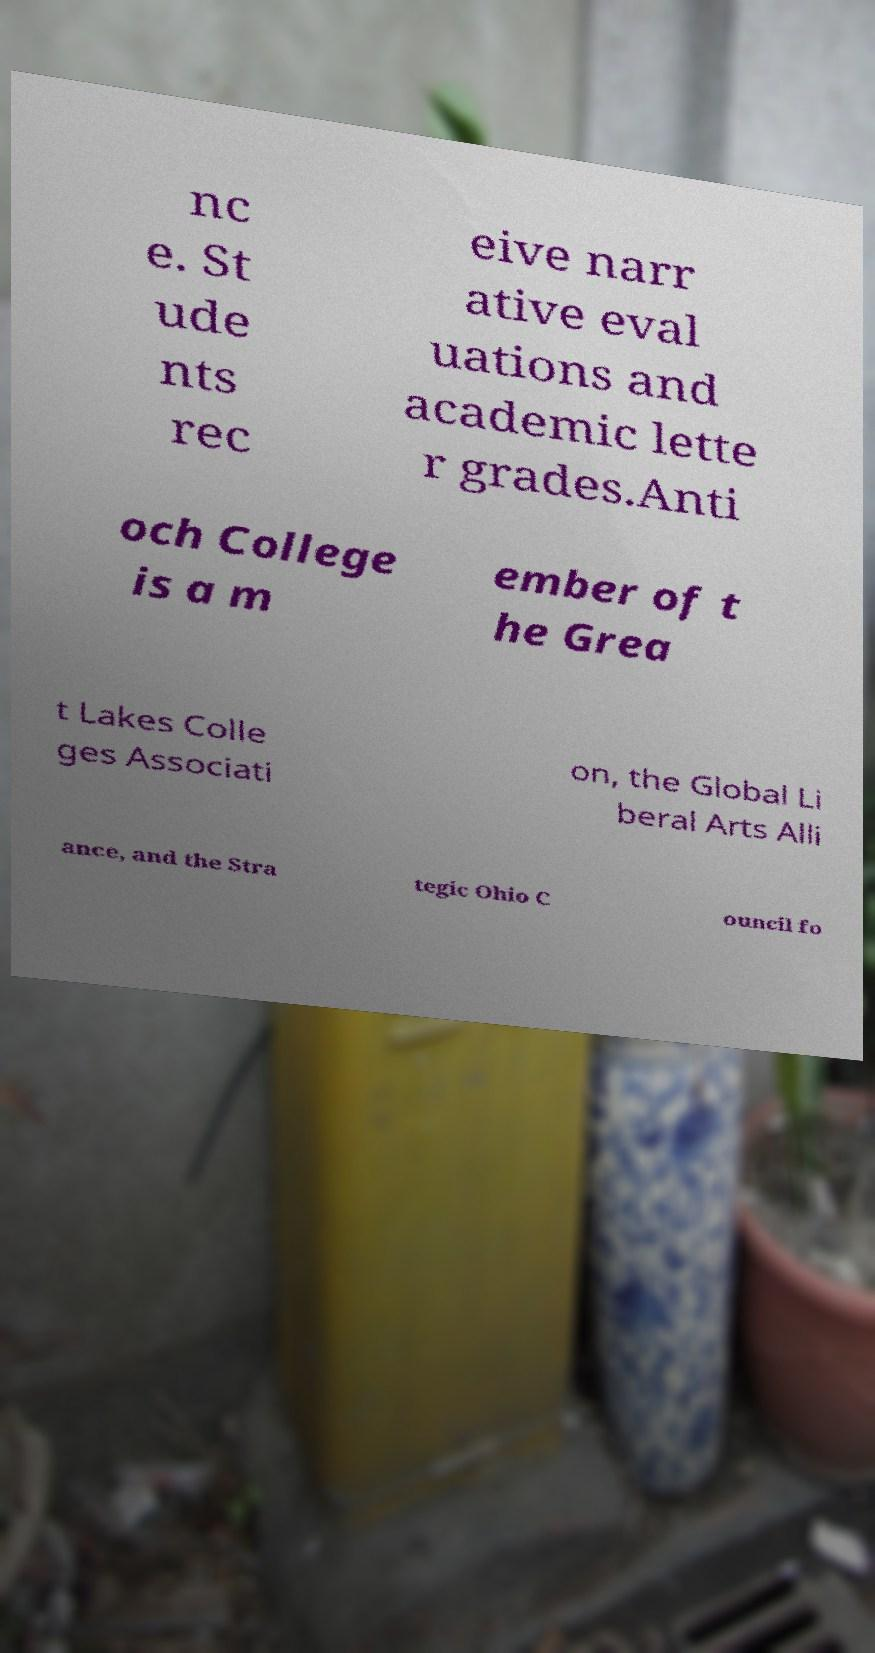I need the written content from this picture converted into text. Can you do that? nc e. St ude nts rec eive narr ative eval uations and academic lette r grades.Anti och College is a m ember of t he Grea t Lakes Colle ges Associati on, the Global Li beral Arts Alli ance, and the Stra tegic Ohio C ouncil fo 